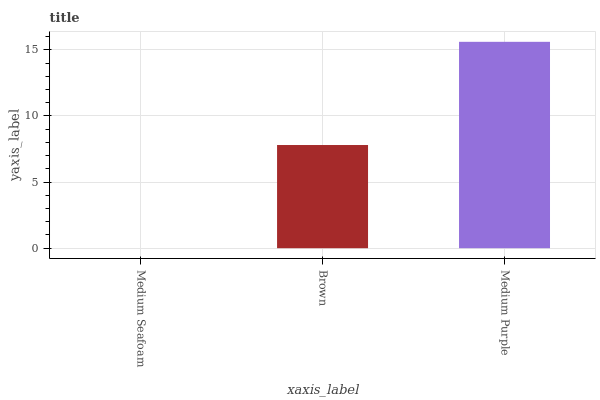Is Medium Seafoam the minimum?
Answer yes or no. Yes. Is Medium Purple the maximum?
Answer yes or no. Yes. Is Brown the minimum?
Answer yes or no. No. Is Brown the maximum?
Answer yes or no. No. Is Brown greater than Medium Seafoam?
Answer yes or no. Yes. Is Medium Seafoam less than Brown?
Answer yes or no. Yes. Is Medium Seafoam greater than Brown?
Answer yes or no. No. Is Brown less than Medium Seafoam?
Answer yes or no. No. Is Brown the high median?
Answer yes or no. Yes. Is Brown the low median?
Answer yes or no. Yes. Is Medium Purple the high median?
Answer yes or no. No. Is Medium Seafoam the low median?
Answer yes or no. No. 